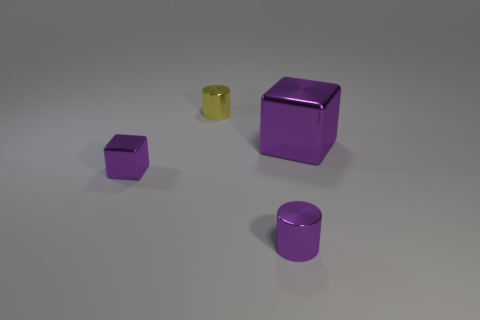There is a cube that is behind the small purple metal object behind the cylinder that is on the right side of the yellow thing; what is its size?
Make the answer very short. Large. There is another cube that is made of the same material as the tiny purple cube; what size is it?
Your response must be concise. Large. Does the purple metal cylinder have the same size as the cylinder behind the small metal block?
Offer a very short reply. Yes. There is a yellow shiny thing that is behind the large purple object; what shape is it?
Offer a terse response. Cylinder. There is a cylinder that is in front of the cube to the right of the tiny purple metal cylinder; are there any tiny metallic cylinders that are left of it?
Your answer should be very brief. Yes. There is another object that is the same shape as the tiny yellow metal object; what is it made of?
Make the answer very short. Metal. What number of cubes are large metal objects or yellow objects?
Your answer should be very brief. 1. There is a cylinder behind the large purple metallic block; does it have the same size as the cylinder in front of the large shiny block?
Your answer should be very brief. Yes. The small cylinder that is in front of the small object behind the large block is made of what material?
Keep it short and to the point. Metal. Are there fewer tiny purple shiny cubes in front of the yellow thing than metallic cubes?
Offer a very short reply. Yes. 